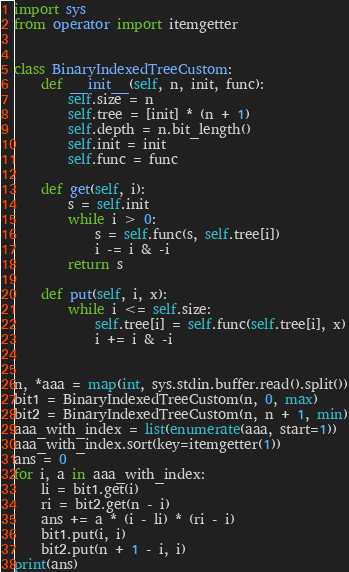<code> <loc_0><loc_0><loc_500><loc_500><_Python_>import sys
from operator import itemgetter


class BinaryIndexedTreeCustom:
    def __init__(self, n, init, func):
        self.size = n
        self.tree = [init] * (n + 1)
        self.depth = n.bit_length()
        self.init = init
        self.func = func

    def get(self, i):
        s = self.init
        while i > 0:
            s = self.func(s, self.tree[i])
            i -= i & -i
        return s

    def put(self, i, x):
        while i <= self.size:
            self.tree[i] = self.func(self.tree[i], x)
            i += i & -i


n, *aaa = map(int, sys.stdin.buffer.read().split())
bit1 = BinaryIndexedTreeCustom(n, 0, max)
bit2 = BinaryIndexedTreeCustom(n, n + 1, min)
aaa_with_index = list(enumerate(aaa, start=1))
aaa_with_index.sort(key=itemgetter(1))
ans = 0
for i, a in aaa_with_index:
    li = bit1.get(i)
    ri = bit2.get(n - i)
    ans += a * (i - li) * (ri - i)
    bit1.put(i, i)
    bit2.put(n + 1 - i, i)
print(ans)
</code> 